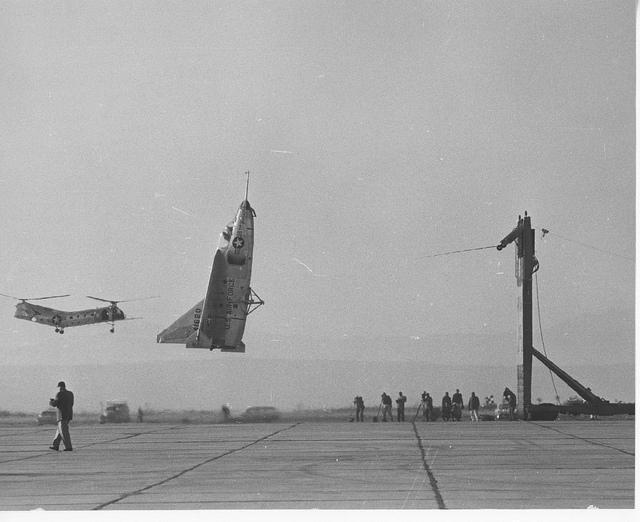How many propellers does the helicopter have?
Give a very brief answer. 2. 